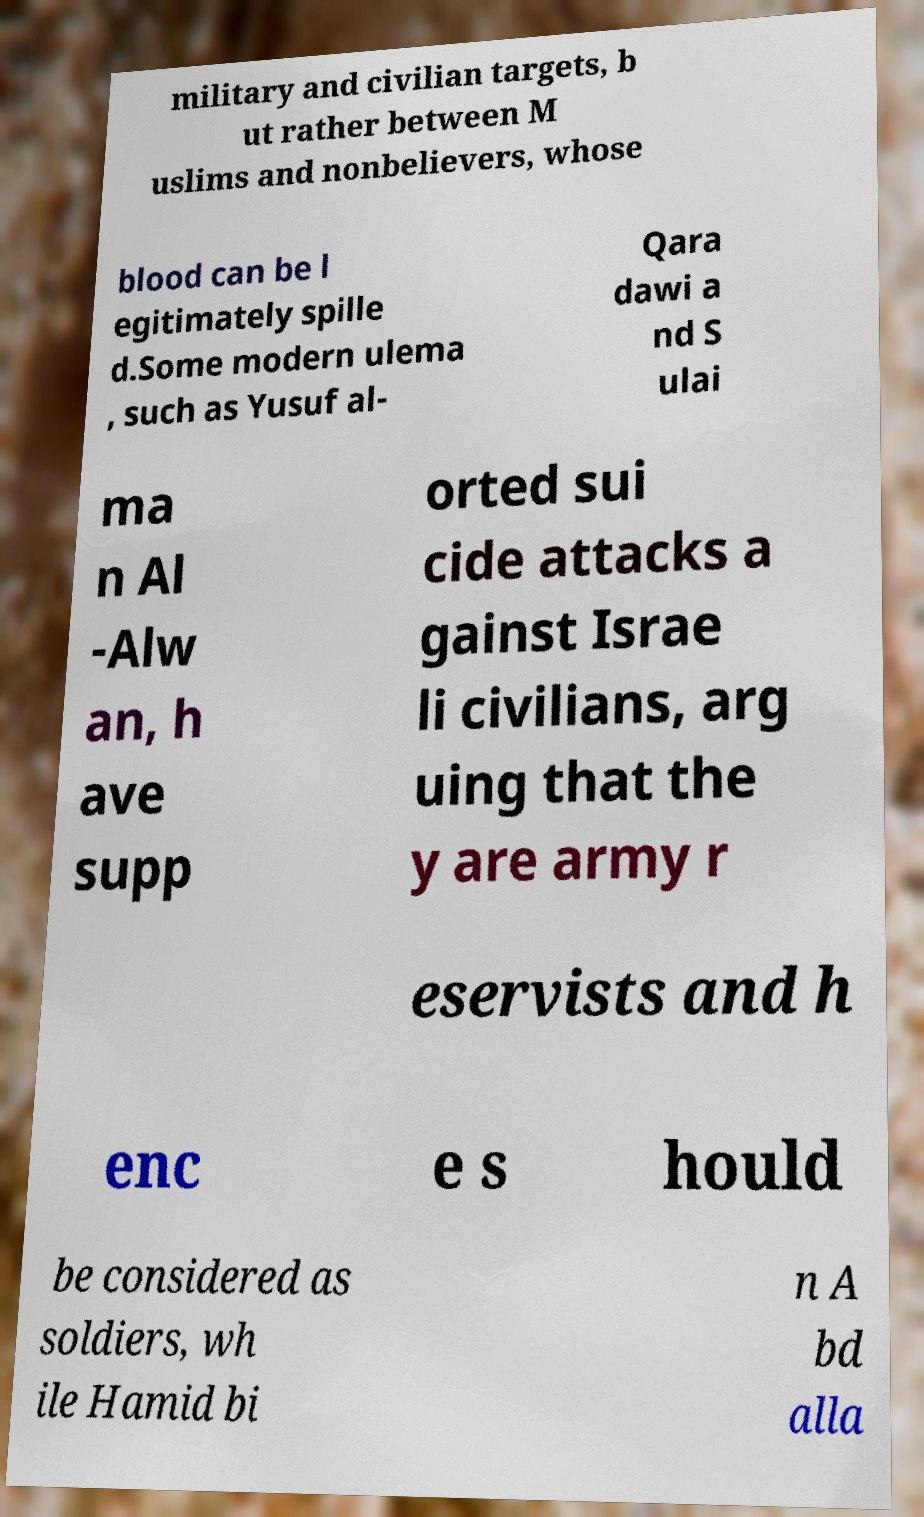Please read and relay the text visible in this image. What does it say? military and civilian targets, b ut rather between M uslims and nonbelievers, whose blood can be l egitimately spille d.Some modern ulema , such as Yusuf al- Qara dawi a nd S ulai ma n Al -Alw an, h ave supp orted sui cide attacks a gainst Israe li civilians, arg uing that the y are army r eservists and h enc e s hould be considered as soldiers, wh ile Hamid bi n A bd alla 